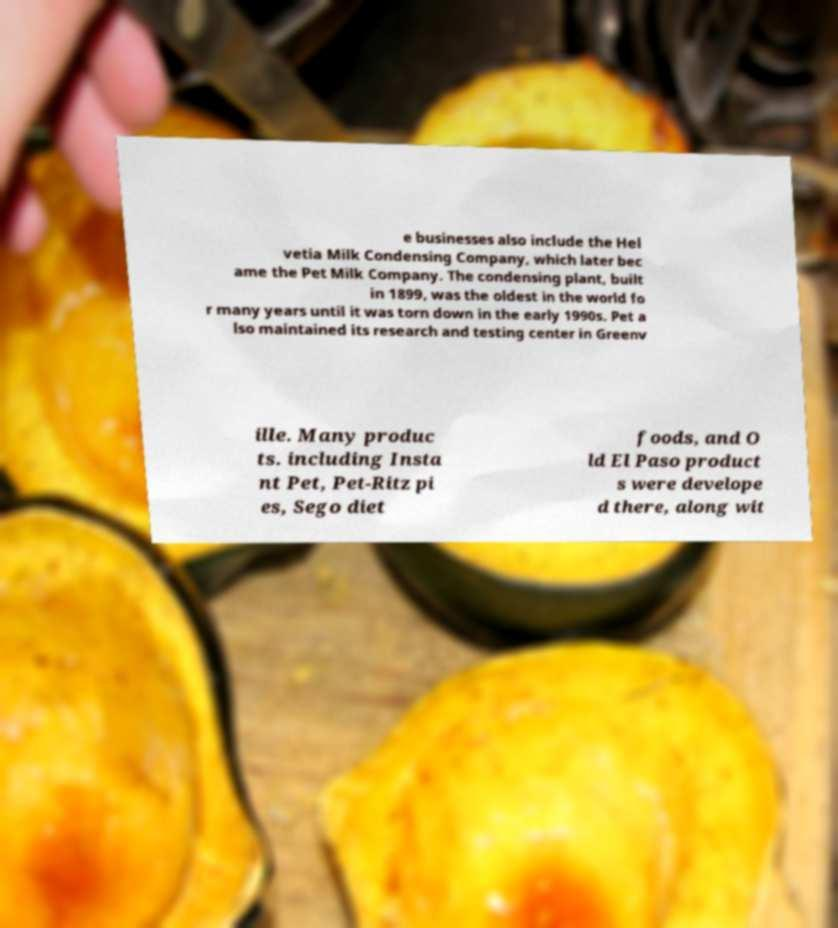Please read and relay the text visible in this image. What does it say? e businesses also include the Hel vetia Milk Condensing Company, which later bec ame the Pet Milk Company. The condensing plant, built in 1899, was the oldest in the world fo r many years until it was torn down in the early 1990s. Pet a lso maintained its research and testing center in Greenv ille. Many produc ts. including Insta nt Pet, Pet-Ritz pi es, Sego diet foods, and O ld El Paso product s were develope d there, along wit 